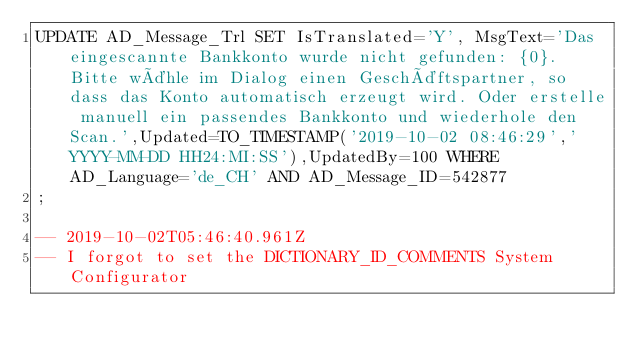<code> <loc_0><loc_0><loc_500><loc_500><_SQL_>UPDATE AD_Message_Trl SET IsTranslated='Y', MsgText='Das eingescannte Bankkonto wurde nicht gefunden: {0}. Bitte wähle im Dialog einen Geschäftspartner, so dass das Konto automatisch erzeugt wird. Oder erstelle manuell ein passendes Bankkonto und wiederhole den Scan.',Updated=TO_TIMESTAMP('2019-10-02 08:46:29','YYYY-MM-DD HH24:MI:SS'),UpdatedBy=100 WHERE AD_Language='de_CH' AND AD_Message_ID=542877
;

-- 2019-10-02T05:46:40.961Z
-- I forgot to set the DICTIONARY_ID_COMMENTS System Configurator</code> 